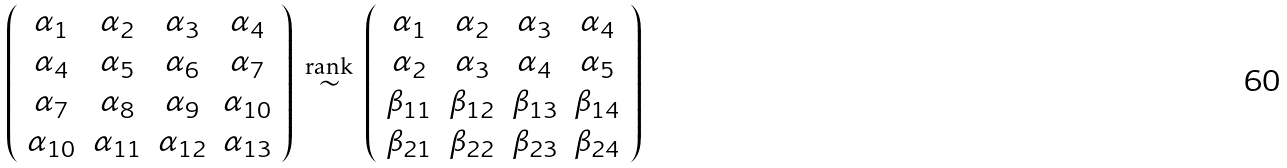Convert formula to latex. <formula><loc_0><loc_0><loc_500><loc_500>\left ( \begin{array} { c c c c } \alpha _ { 1 } & \alpha _ { 2 } & \alpha _ { 3 } & \alpha _ { 4 } \\ \alpha _ { 4 } & \alpha _ { 5 } & \alpha _ { 6 } & \alpha _ { 7 } \\ \alpha _ { 7 } & \alpha _ { 8 } & \alpha _ { 9 } & \alpha _ { 1 0 } \\ \alpha _ { 1 0 } & \alpha _ { 1 1 } & \alpha _ { 1 2 } & \alpha _ { 1 3 } \end{array} \right ) \, \overset { \text {rank} } { \sim } \, \left ( \begin{array} { c c c c } \alpha _ { 1 } & \alpha _ { 2 } & \alpha _ { 3 } & \alpha _ { 4 } \\ \alpha _ { 2 } & \alpha _ { 3 } & \alpha _ { 4 } & \alpha _ { 5 } \\ \beta _ { 1 1 } & \beta _ { 1 2 } & \beta _ { 1 3 } & \beta _ { 1 4 } \\ \beta _ { 2 1 } & \beta _ { 2 2 } & \beta _ { 2 3 } & \beta _ { 2 4 } \end{array} \right )</formula> 